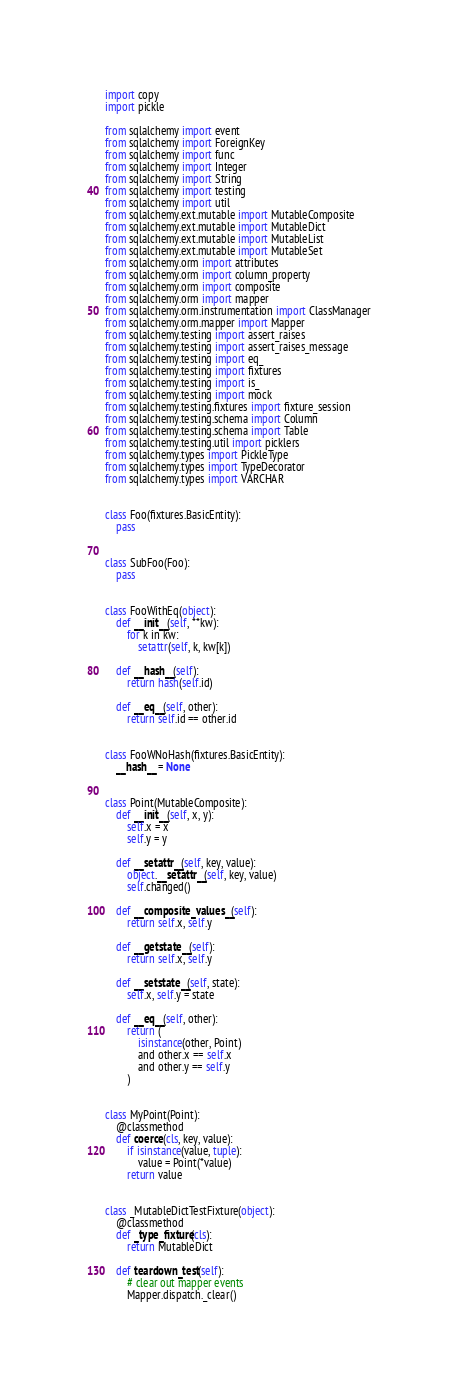<code> <loc_0><loc_0><loc_500><loc_500><_Python_>import copy
import pickle

from sqlalchemy import event
from sqlalchemy import ForeignKey
from sqlalchemy import func
from sqlalchemy import Integer
from sqlalchemy import String
from sqlalchemy import testing
from sqlalchemy import util
from sqlalchemy.ext.mutable import MutableComposite
from sqlalchemy.ext.mutable import MutableDict
from sqlalchemy.ext.mutable import MutableList
from sqlalchemy.ext.mutable import MutableSet
from sqlalchemy.orm import attributes
from sqlalchemy.orm import column_property
from sqlalchemy.orm import composite
from sqlalchemy.orm import mapper
from sqlalchemy.orm.instrumentation import ClassManager
from sqlalchemy.orm.mapper import Mapper
from sqlalchemy.testing import assert_raises
from sqlalchemy.testing import assert_raises_message
from sqlalchemy.testing import eq_
from sqlalchemy.testing import fixtures
from sqlalchemy.testing import is_
from sqlalchemy.testing import mock
from sqlalchemy.testing.fixtures import fixture_session
from sqlalchemy.testing.schema import Column
from sqlalchemy.testing.schema import Table
from sqlalchemy.testing.util import picklers
from sqlalchemy.types import PickleType
from sqlalchemy.types import TypeDecorator
from sqlalchemy.types import VARCHAR


class Foo(fixtures.BasicEntity):
    pass


class SubFoo(Foo):
    pass


class FooWithEq(object):
    def __init__(self, **kw):
        for k in kw:
            setattr(self, k, kw[k])

    def __hash__(self):
        return hash(self.id)

    def __eq__(self, other):
        return self.id == other.id


class FooWNoHash(fixtures.BasicEntity):
    __hash__ = None


class Point(MutableComposite):
    def __init__(self, x, y):
        self.x = x
        self.y = y

    def __setattr__(self, key, value):
        object.__setattr__(self, key, value)
        self.changed()

    def __composite_values__(self):
        return self.x, self.y

    def __getstate__(self):
        return self.x, self.y

    def __setstate__(self, state):
        self.x, self.y = state

    def __eq__(self, other):
        return (
            isinstance(other, Point)
            and other.x == self.x
            and other.y == self.y
        )


class MyPoint(Point):
    @classmethod
    def coerce(cls, key, value):
        if isinstance(value, tuple):
            value = Point(*value)
        return value


class _MutableDictTestFixture(object):
    @classmethod
    def _type_fixture(cls):
        return MutableDict

    def teardown_test(self):
        # clear out mapper events
        Mapper.dispatch._clear()</code> 